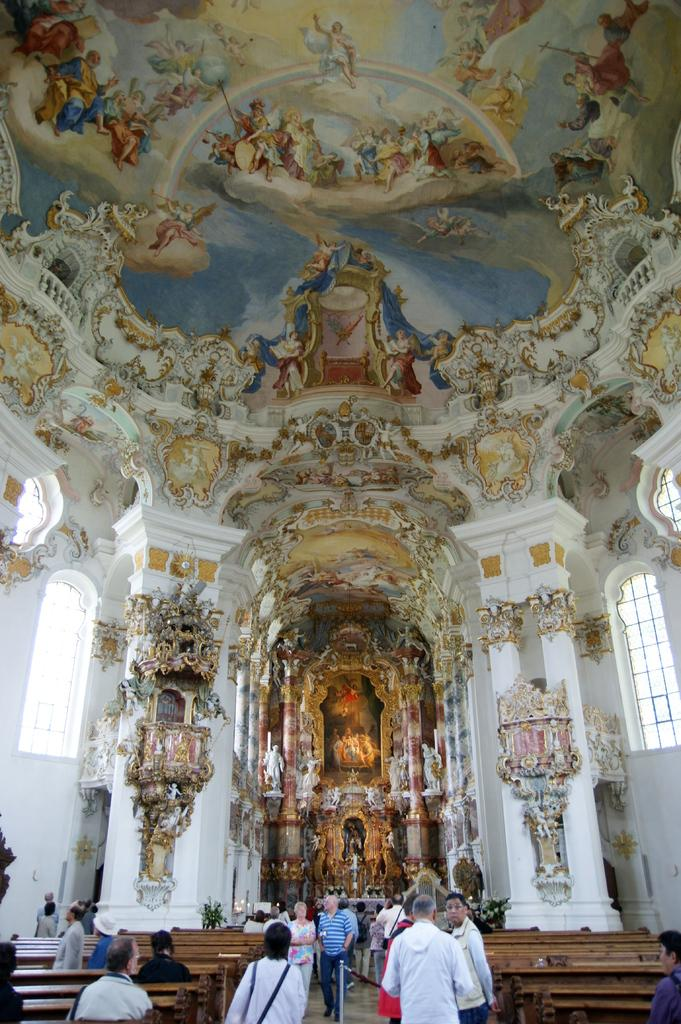What are the people in the image doing? There is a group of people standing and people sitting on benches in the image. What can be seen in the background of the image? There are windows in the image. Are there any artistic elements in the image? Yes, there are sculptures and paintings on the top of the image. Can you see the ocean in the image? No, there is no ocean visible in the image. What type of zephyr is present in the image? There is no zephyr present in the image, as it refers to a gentle breeze, which cannot be seen. 